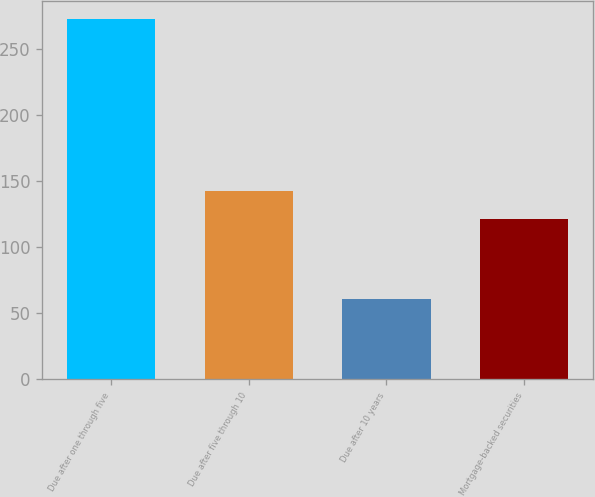<chart> <loc_0><loc_0><loc_500><loc_500><bar_chart><fcel>Due after one through five<fcel>Due after five through 10<fcel>Due after 10 years<fcel>Mortgage-backed securities<nl><fcel>273<fcel>142.2<fcel>61<fcel>121<nl></chart> 